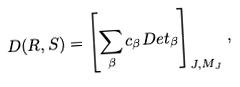<formula> <loc_0><loc_0><loc_500><loc_500>D ( R , S ) = \left [ \sum _ { \beta } c _ { \beta } D e t _ { \beta } \right ] _ { J , M _ { J } } \, ,</formula> 